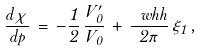Convert formula to latex. <formula><loc_0><loc_0><loc_500><loc_500>\frac { d \chi } { d p } \, = \, - \frac { 1 } { 2 } \, \frac { V ^ { \prime } _ { 0 } } { V _ { 0 } } \, + \, \frac { \ w h h } { 2 \pi } \, \xi _ { 1 } \, ,</formula> 